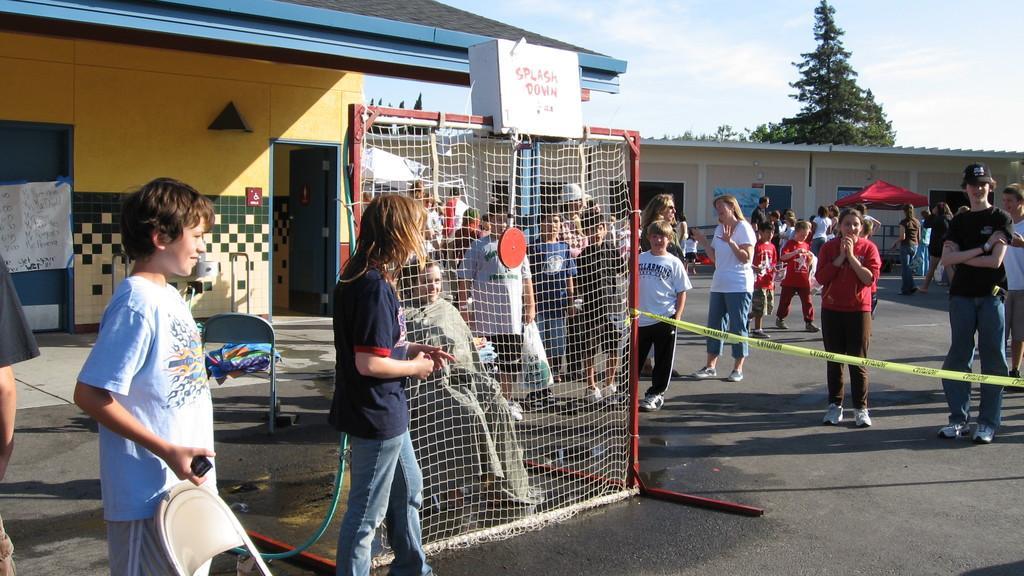Please provide a concise description of this image. In this picture i can see a group of people are standing on the ground. In the background i can see trees, buildings and sky. On the left side i can see wall, doors, chairs and other objects on the ground. In the front i can see a net which has a box on it. 